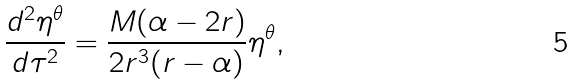Convert formula to latex. <formula><loc_0><loc_0><loc_500><loc_500>\frac { d ^ { 2 } \eta ^ { \theta } } { d \tau ^ { 2 } } = \frac { M ( { \alpha } - 2 r ) } { 2 r ^ { 3 } ( r - { \alpha } ) } \eta ^ { \theta } ,</formula> 